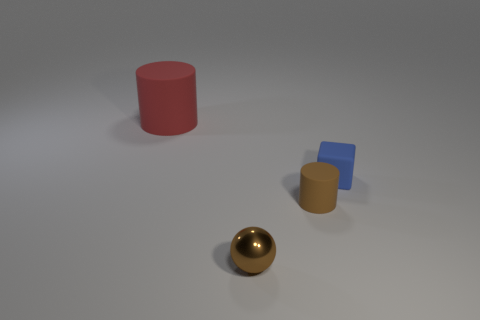Is there a shiny sphere of the same color as the tiny matte cylinder?
Your answer should be very brief. Yes. There is a brown object that is the same size as the brown ball; what is its material?
Provide a short and direct response. Rubber. There is a thing that is behind the small brown matte thing and on the right side of the sphere; what is its color?
Your answer should be very brief. Blue. There is a rubber cylinder to the left of the tiny brown rubber cylinder; is its size the same as the brown cylinder on the right side of the tiny shiny sphere?
Your answer should be compact. No. What color is the other rubber object that is the same shape as the red thing?
Give a very brief answer. Brown. Do the small brown metallic thing and the small blue thing have the same shape?
Offer a terse response. No. There is another thing that is the same shape as the large red matte object; what size is it?
Your answer should be compact. Small. What number of things have the same material as the block?
Offer a very short reply. 2. What number of objects are either small cylinders or gray metallic spheres?
Keep it short and to the point. 1. There is a cylinder that is in front of the small blue matte thing; are there any small rubber blocks in front of it?
Make the answer very short. No. 